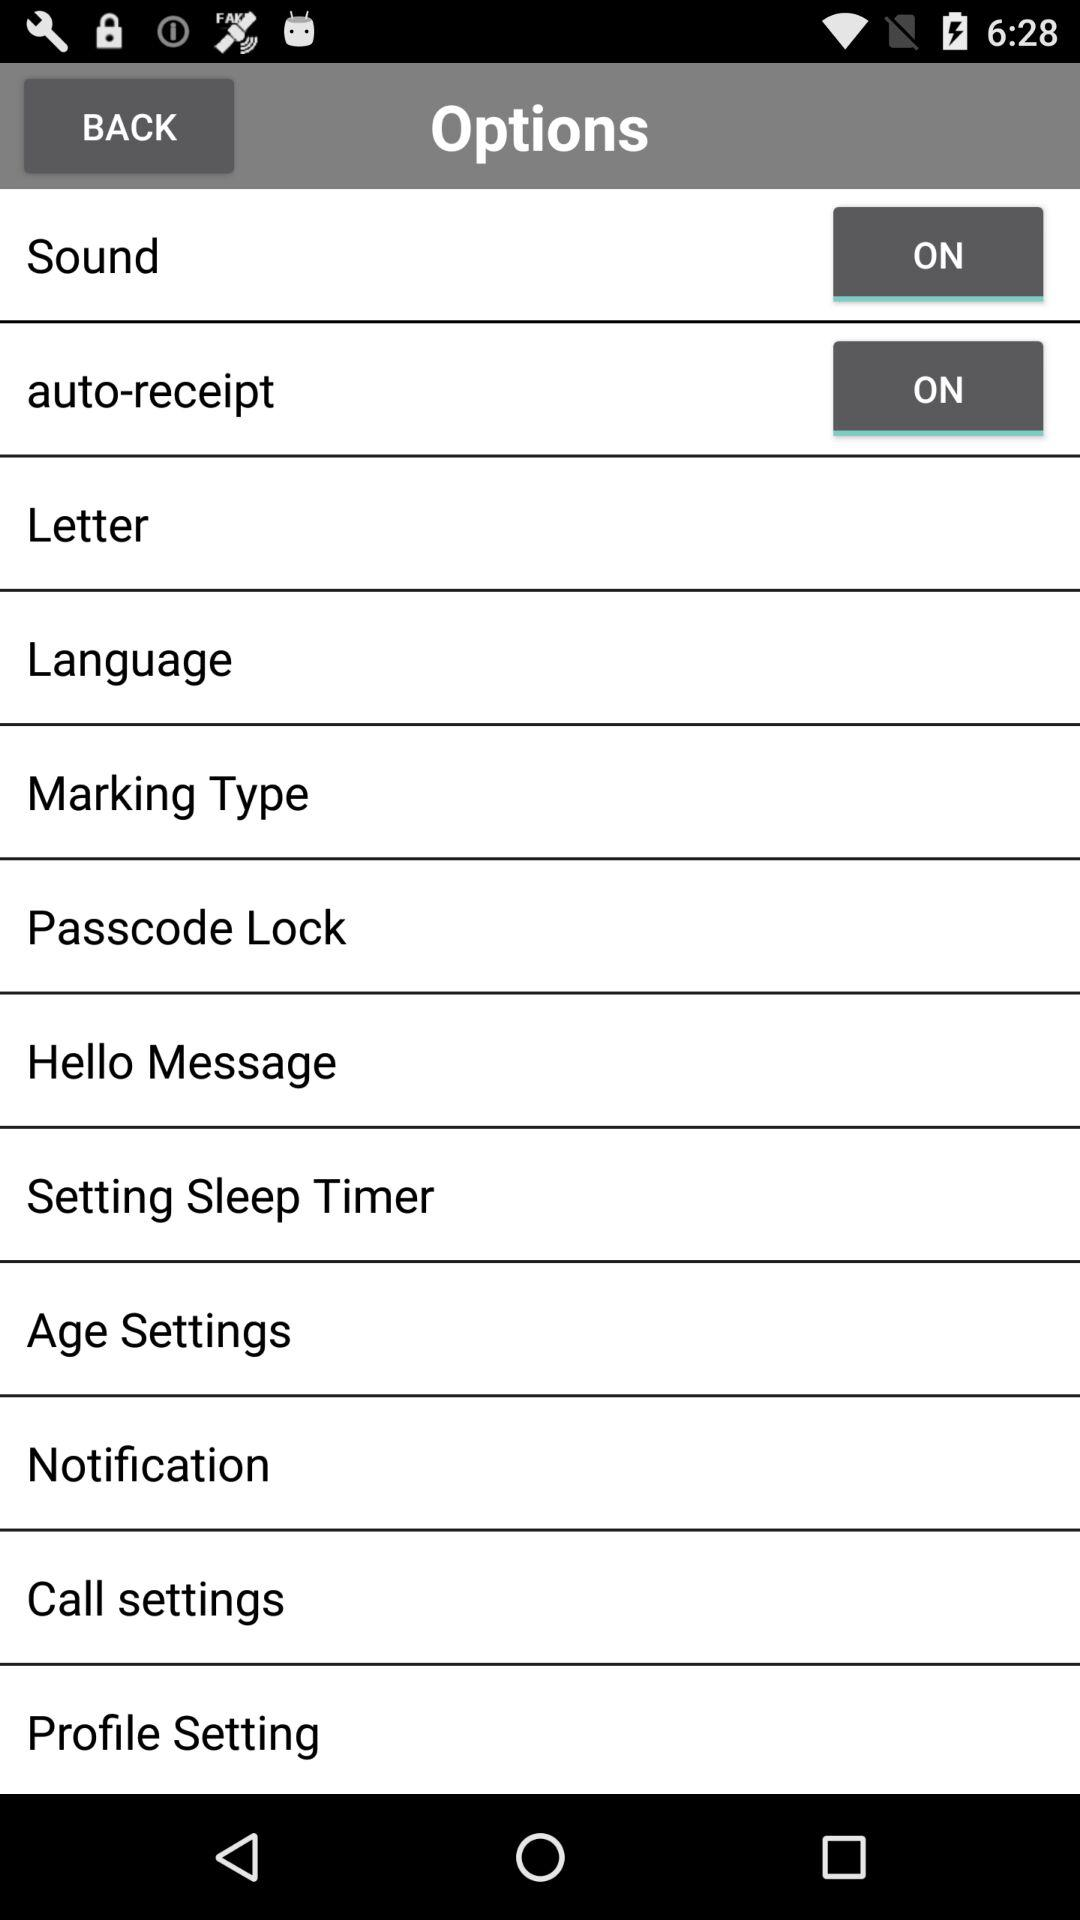What is the status of "Sound" setting? The status is "on". 